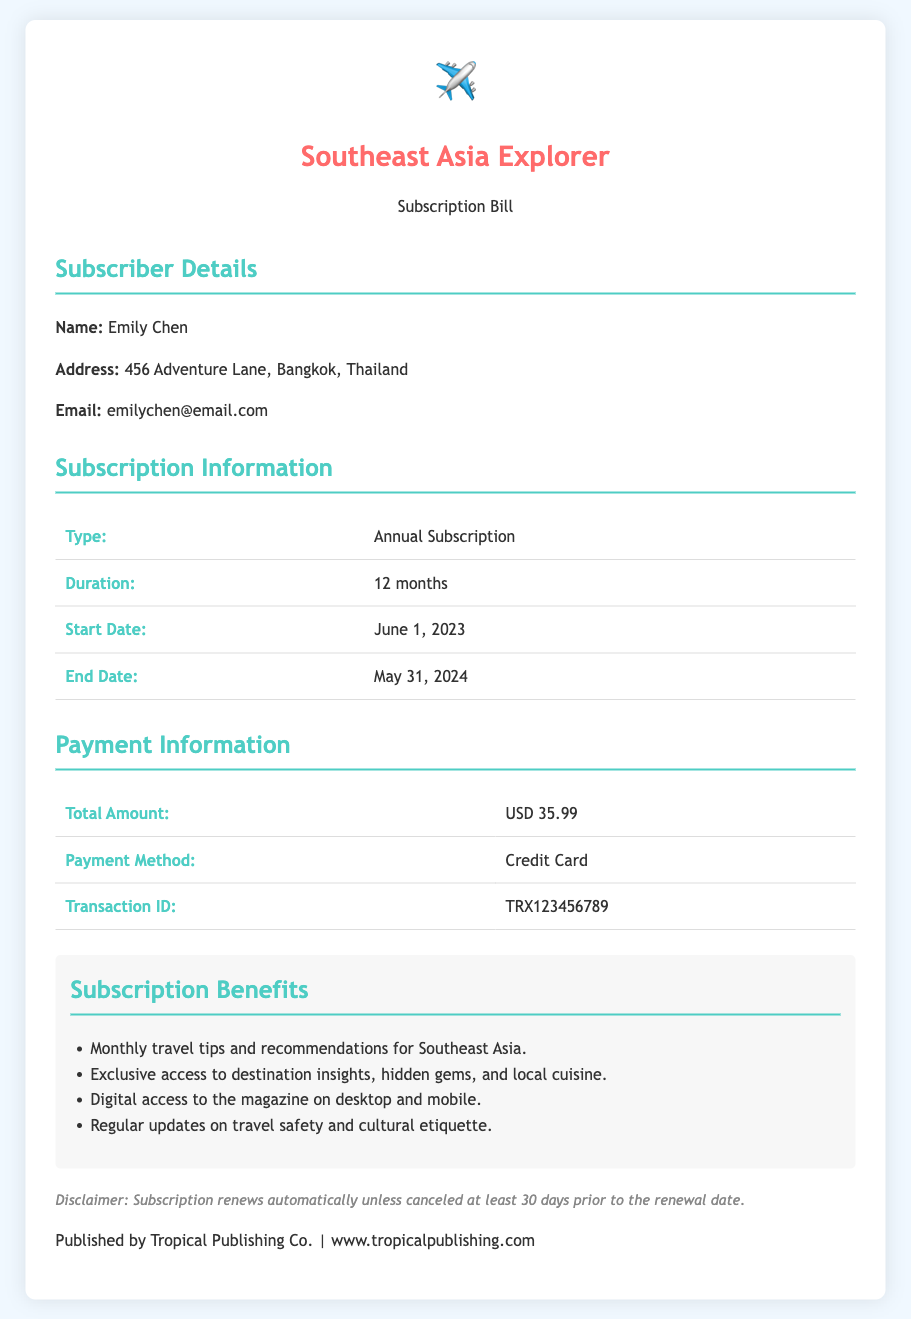what is the subscriber's name? The subscriber's name is prominently mentioned in the subscriber details section.
Answer: Emily Chen what is the subscription type? The document specifies the type of subscription in the subscription information section.
Answer: Annual Subscription when does the subscription start? The start date of the subscription is provided in the subscription information section.
Answer: June 1, 2023 what is the total amount due? The total amount is clearly stated in the payment information section of the document.
Answer: USD 35.99 what is the payment method used? The payment method can be found in the payment information section of the document.
Answer: Credit Card how long is the duration of the subscription? The duration is explicitly stated in the subscription information section.
Answer: 12 months what are some of the subscription benefits? Several benefits are listed in the benefits section of the document.
Answer: Monthly travel tips and recommendations for Southeast Asia when should the subscription be canceled to avoid automatic renewal? The cancellation policy is detailed in the disclaimer at the bottom of the document.
Answer: 30 days prior to renewal date what is the transaction ID? The transaction ID is provided in the payment information section.
Answer: TRX123456789 